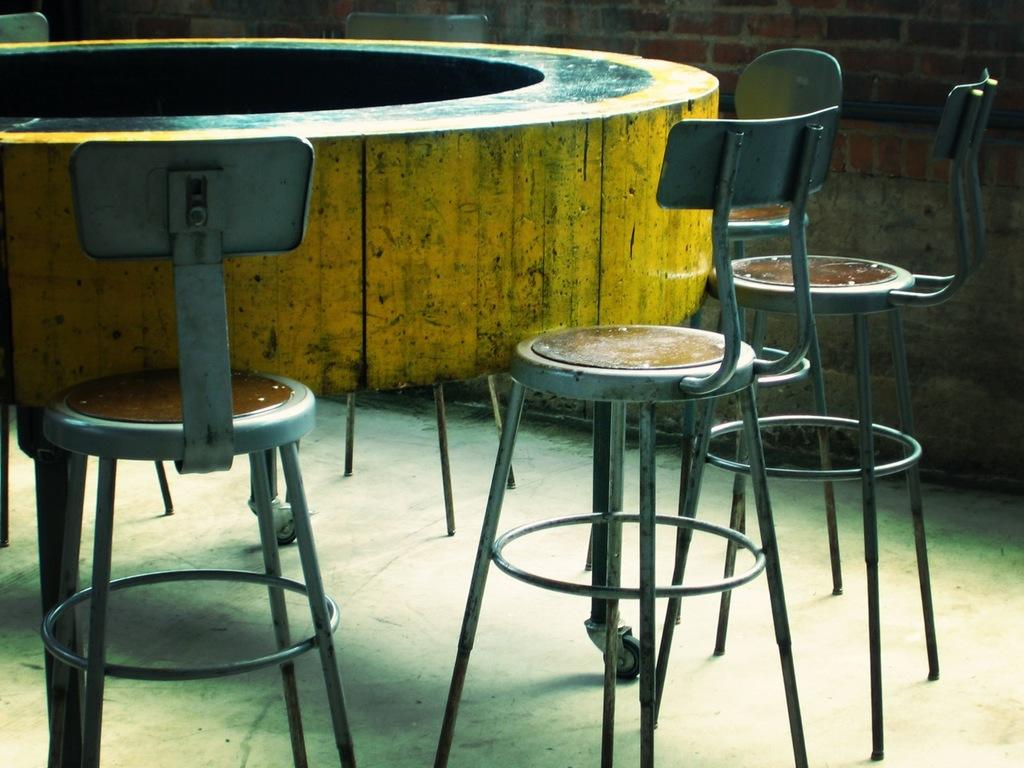What is the wooden object painted with yellow and black color in the image? The wooden object painted with yellow and black color in the image is not specified, but it is mentioned as a prominent feature. How many chairs are visible in the image? There are many chairs in the image. What type of plant can be seen growing near the chairs in the image? There is no plant visible in the image; it only mentions a wooden object painted with yellow and black color and many chairs. What time of day is depicted in the image, considering the presence of a loaf? There is no loaf present in the image, so it is not possible to determine the time of day based on that information. 